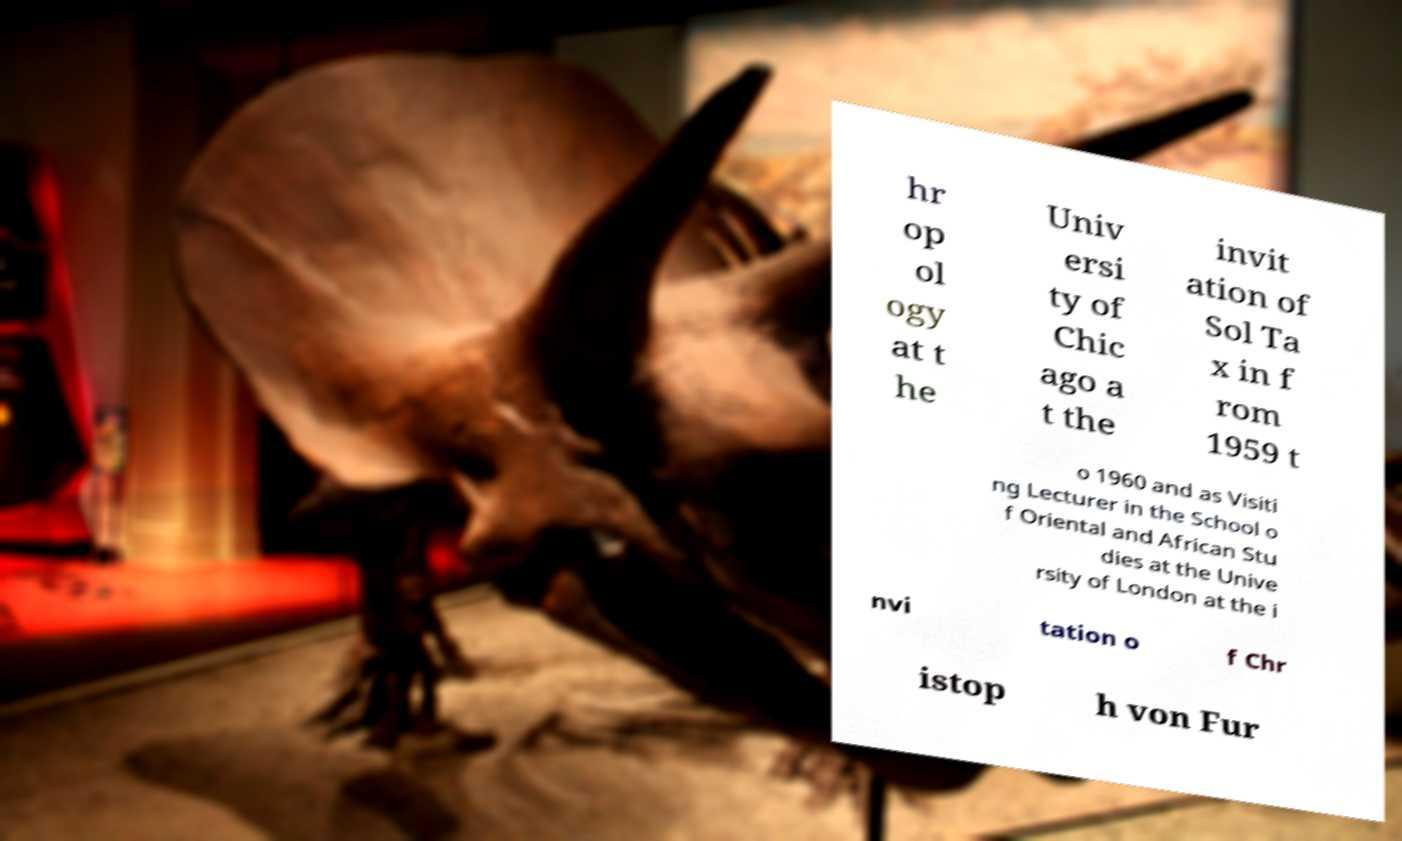Could you assist in decoding the text presented in this image and type it out clearly? hr op ol ogy at t he Univ ersi ty of Chic ago a t the invit ation of Sol Ta x in f rom 1959 t o 1960 and as Visiti ng Lecturer in the School o f Oriental and African Stu dies at the Unive rsity of London at the i nvi tation o f Chr istop h von Fur 